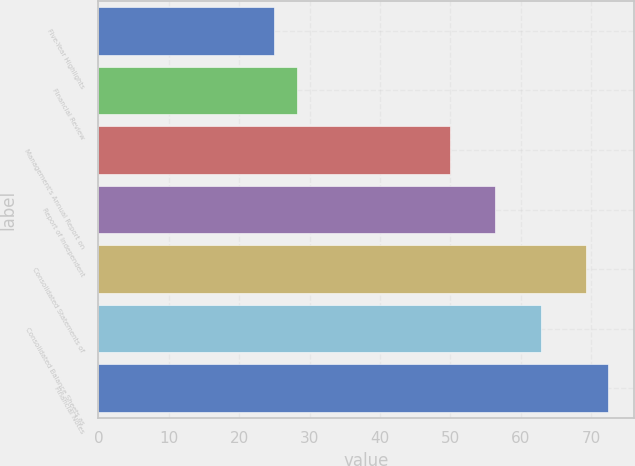<chart> <loc_0><loc_0><loc_500><loc_500><bar_chart><fcel>Five-Year Highlights<fcel>Financial Review<fcel>Management's Annual Report on<fcel>Report of Independent<fcel>Consolidated Statements of<fcel>Consolidated Balance Sheets as<fcel>Financial Notes<nl><fcel>25<fcel>28.2<fcel>50<fcel>56.4<fcel>69.2<fcel>62.8<fcel>72.4<nl></chart> 